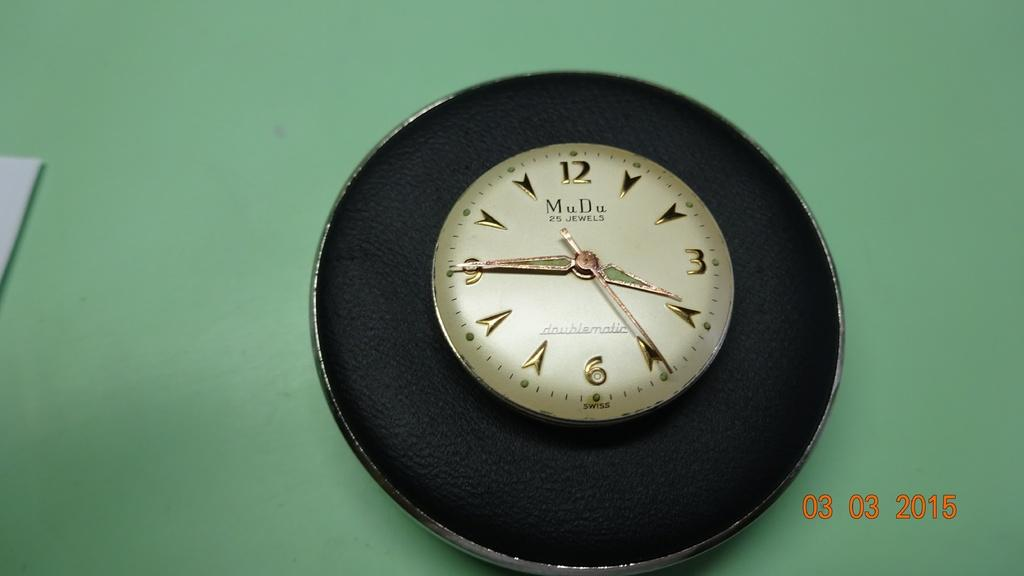<image>
Share a concise interpretation of the image provided. A clock that says MuDu is on a green wall. 